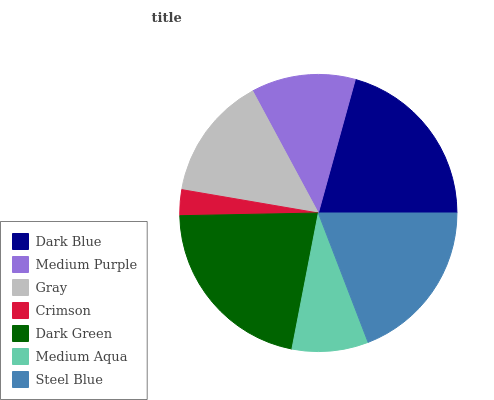Is Crimson the minimum?
Answer yes or no. Yes. Is Dark Green the maximum?
Answer yes or no. Yes. Is Medium Purple the minimum?
Answer yes or no. No. Is Medium Purple the maximum?
Answer yes or no. No. Is Dark Blue greater than Medium Purple?
Answer yes or no. Yes. Is Medium Purple less than Dark Blue?
Answer yes or no. Yes. Is Medium Purple greater than Dark Blue?
Answer yes or no. No. Is Dark Blue less than Medium Purple?
Answer yes or no. No. Is Gray the high median?
Answer yes or no. Yes. Is Gray the low median?
Answer yes or no. Yes. Is Medium Purple the high median?
Answer yes or no. No. Is Crimson the low median?
Answer yes or no. No. 